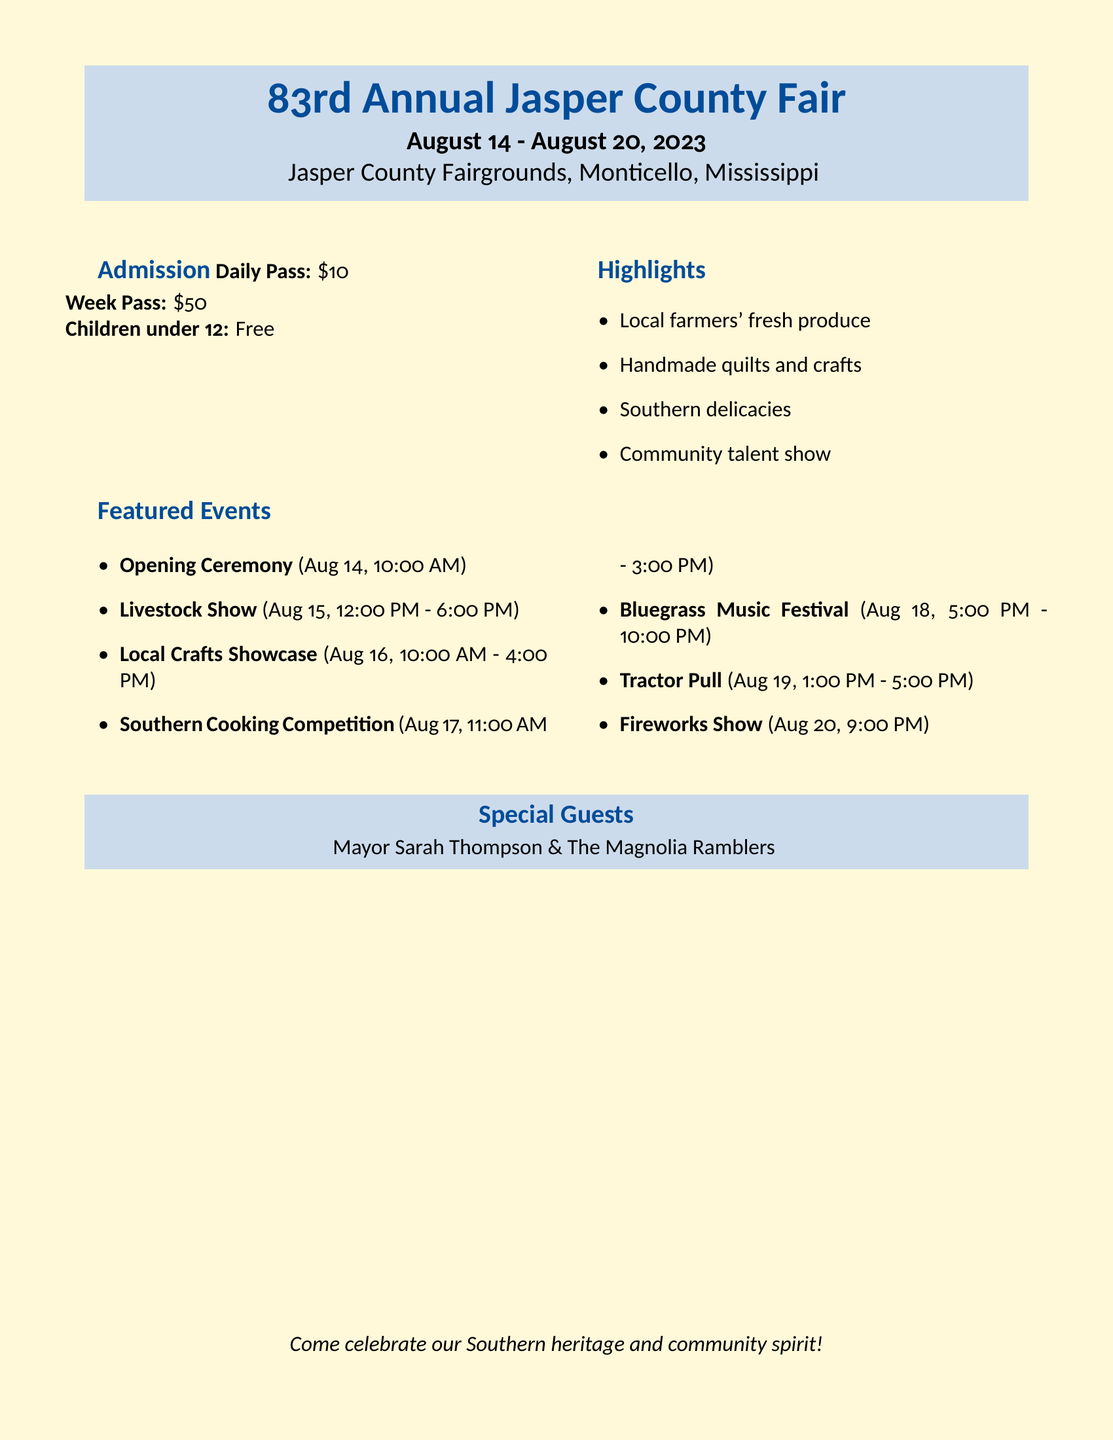What are the dates of the fair? The dates are mentioned clearly at the top of the document.
Answer: August 14 - August 20, 2023 What is the cost of a daily pass? The document specifies the admission costs under the Admission section.
Answer: $10 Who will be performing at the fair? The Special Guests section lists the performing entities at the fair.
Answer: Mayor Sarah Thompson & The Magnolia Ramblers What is one of the highlights of the fair? The highlights mentioned are listed in the Highlights section.
Answer: Local farmers' fresh produce On what date and time is the Fireworks Show scheduled? The date and time are listed under the Featured Events section.
Answer: August 20, 9:00 PM What type of competition will take place on August 17? The competition type can be found in the list of Featured Events.
Answer: Southern Cooking Competition How much is the week pass for the fair? The week pass cost is also specified in the Admission section.
Answer: $50 What is the last event happening on August 19? The last event of the day is mentioned under the Featured Events section.
Answer: Tractor Pull 